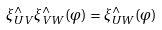<formula> <loc_0><loc_0><loc_500><loc_500>\xi ^ { \wedge } _ { U V } \xi ^ { \wedge } _ { V W } ( \varphi ) = \xi ^ { \wedge } _ { U W } ( \varphi )</formula> 